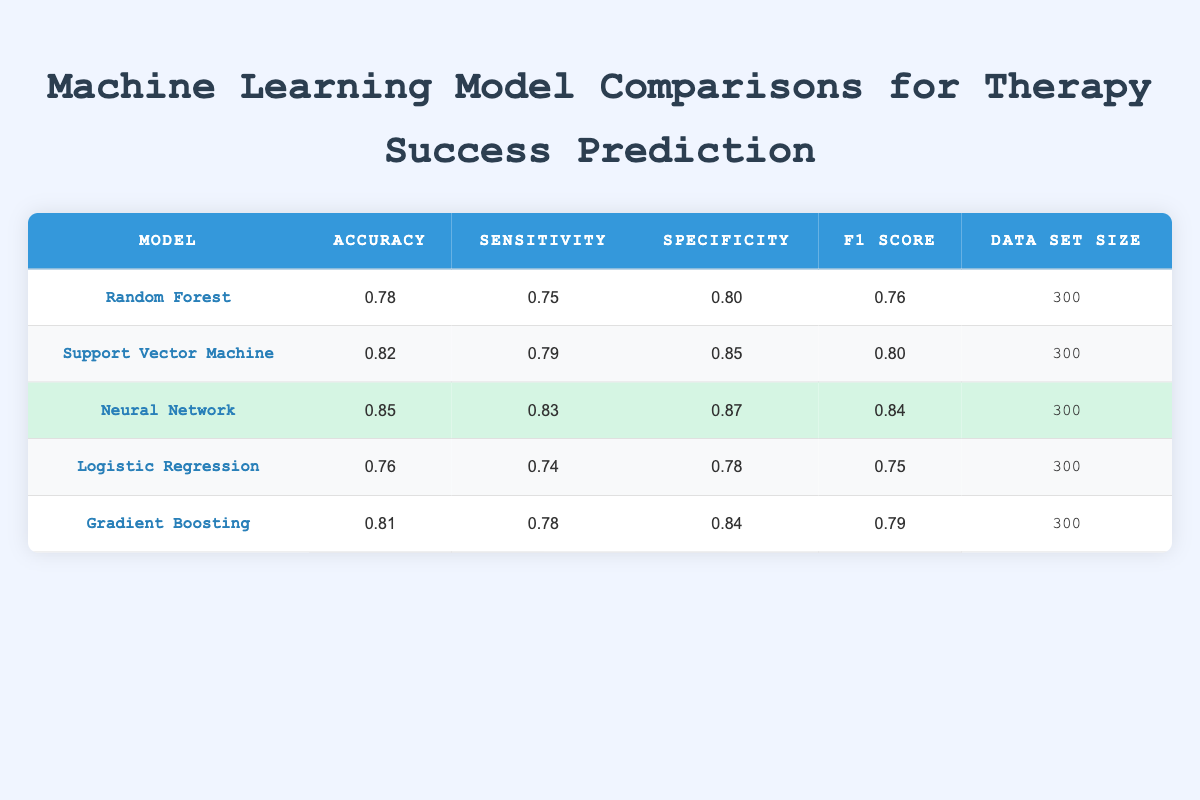What is the accuracy of the Neural Network model? The accuracy value for the Neural Network model can be directly retrieved from the table, which states it is 0.85.
Answer: 0.85 Which model has the highest sensitivity? By comparing the sensitivity values in the table, the Neural Network has the highest sensitivity at 0.83 compared to other models.
Answer: Neural Network What is the difference in accuracy between the Support Vector Machine and Logistic Regression? The accuracy of the Support Vector Machine is 0.82, and the accuracy of Logistic Regression is 0.76. The difference is calculated as 0.82 - 0.76 = 0.06.
Answer: 0.06 Is the specificity of Gradient Boosting greater than that of Random Forest? The specificity of Gradient Boosting is 0.84, while the specificity of Random Forest is 0.80. Since 0.84 is greater than 0.80, the statement is true.
Answer: Yes What is the average accuracy of all the models listed in the table? We first sum the accuracy values: 0.78 + 0.82 + 0.85 + 0.76 + 0.81 = 4.02. There are 5 models, so the average is 4.02 / 5 = 0.804.
Answer: 0.804 Which model has the lowest F1 Score? Looking at the F1 Score values in the table, Logistic Regression has the lowest score at 0.75 compared to other models.
Answer: Logistic Regression If we consider only models with an accuracy above 0.80, how many models are there? The models with an accuracy above 0.80 are Support Vector Machine (0.82), Neural Network (0.85), and Gradient Boosting (0.81), which totals to 3 models.
Answer: 3 What is the specificity of the Support Vector Machine? The table lists the specificity for the Support Vector Machine as 0.85, which can be found easily in the respective row.
Answer: 0.85 Which two models have similar accuracy values and what are they? After inspecting the table, Gradient Boosting and Support Vector Machine both have accuracies of 0.81 and 0.82, respectively, which are close to each other but only differ by 0.01.
Answer: Gradient Boosting and Support Vector Machine (0.81 and 0.82) 